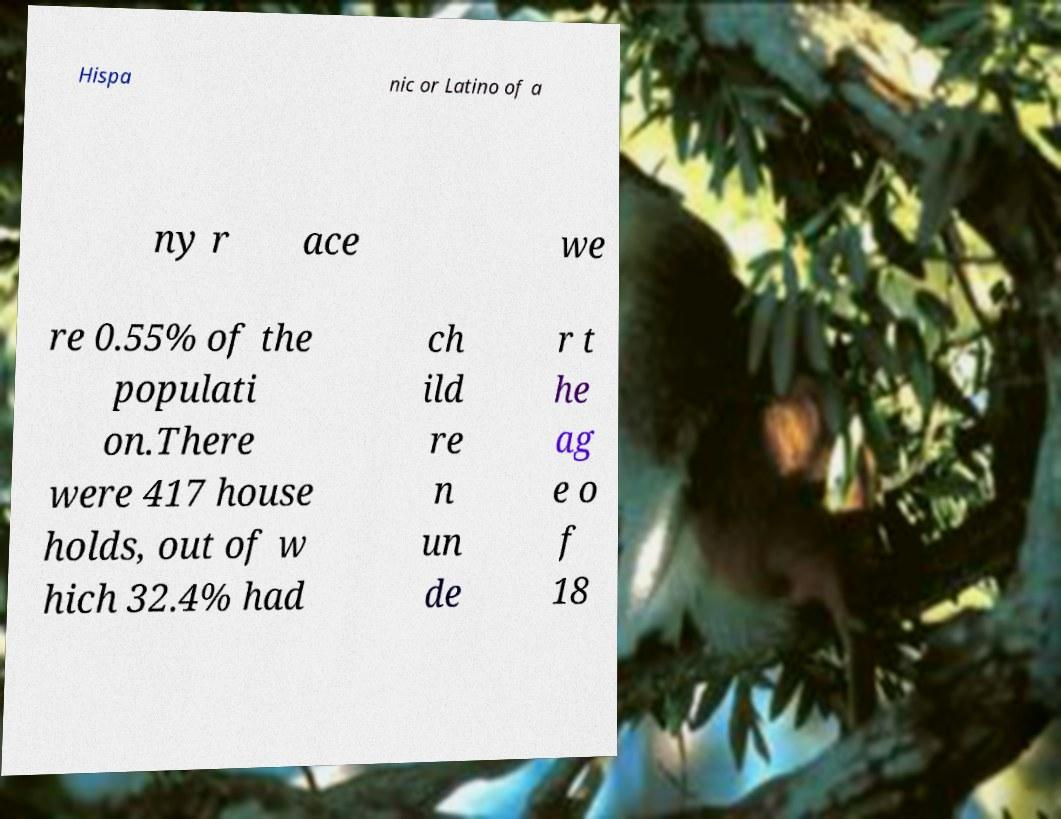There's text embedded in this image that I need extracted. Can you transcribe it verbatim? Hispa nic or Latino of a ny r ace we re 0.55% of the populati on.There were 417 house holds, out of w hich 32.4% had ch ild re n un de r t he ag e o f 18 